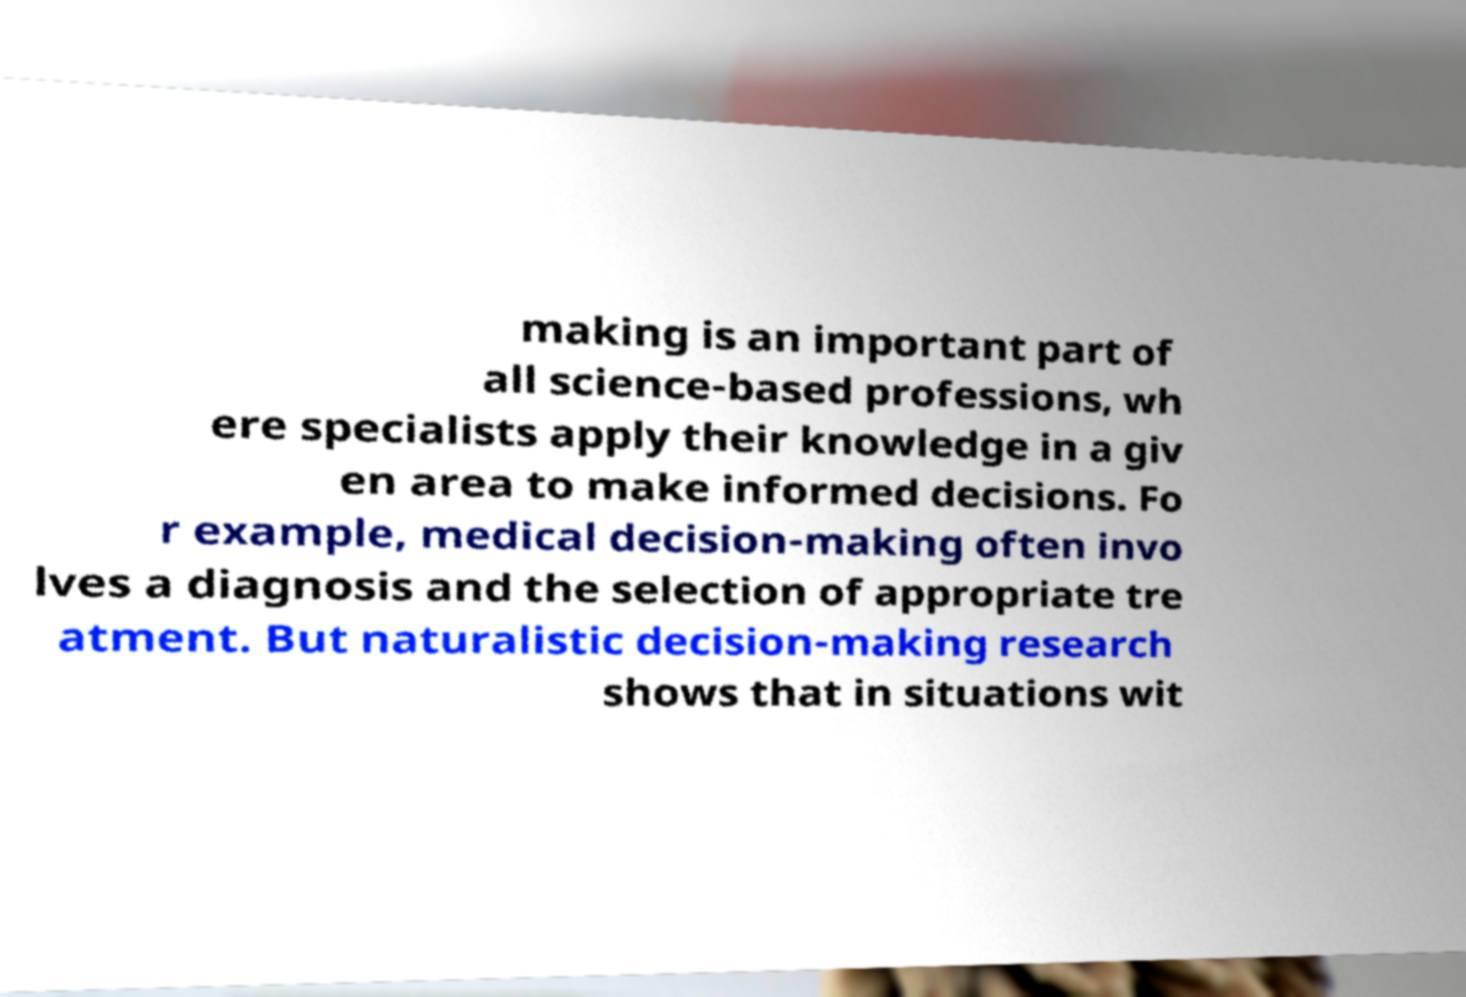For documentation purposes, I need the text within this image transcribed. Could you provide that? making is an important part of all science-based professions, wh ere specialists apply their knowledge in a giv en area to make informed decisions. Fo r example, medical decision-making often invo lves a diagnosis and the selection of appropriate tre atment. But naturalistic decision-making research shows that in situations wit 